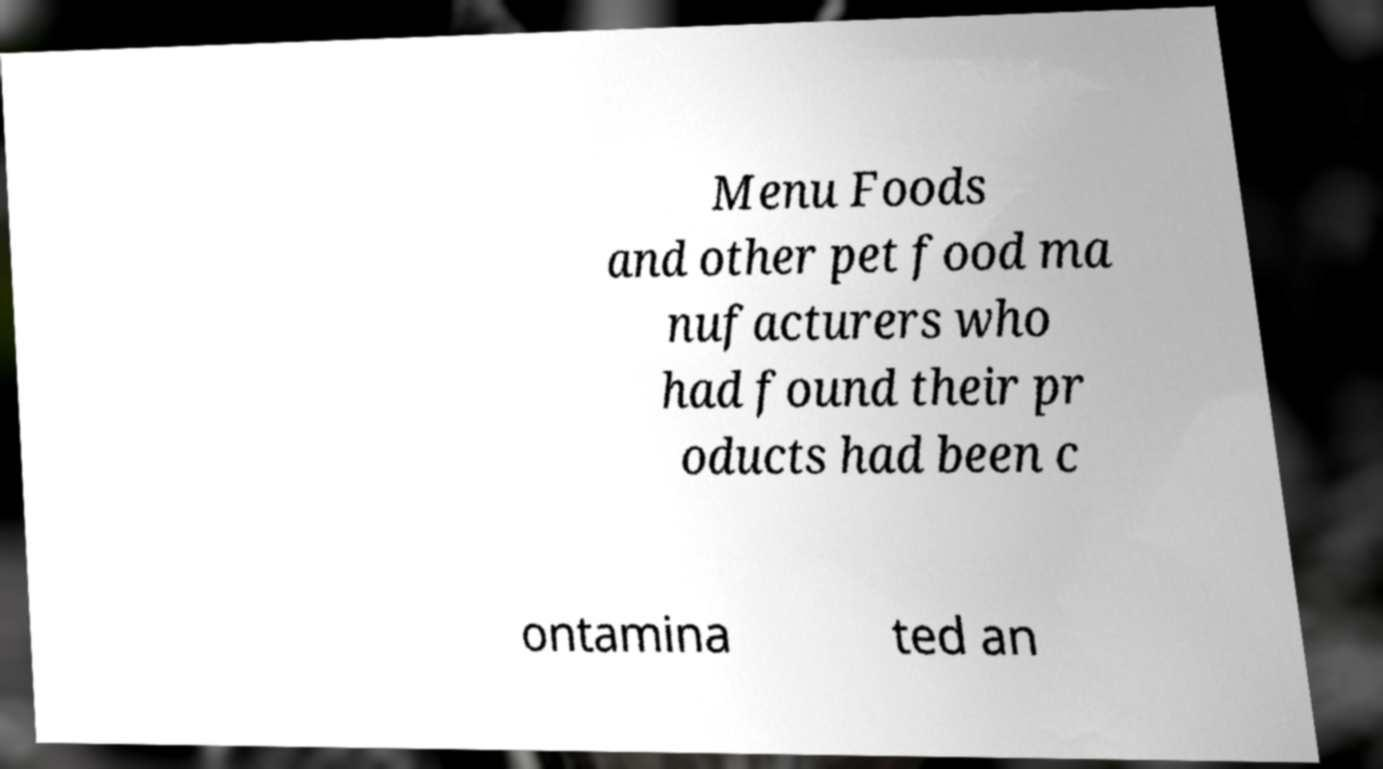Could you extract and type out the text from this image? Menu Foods and other pet food ma nufacturers who had found their pr oducts had been c ontamina ted an 